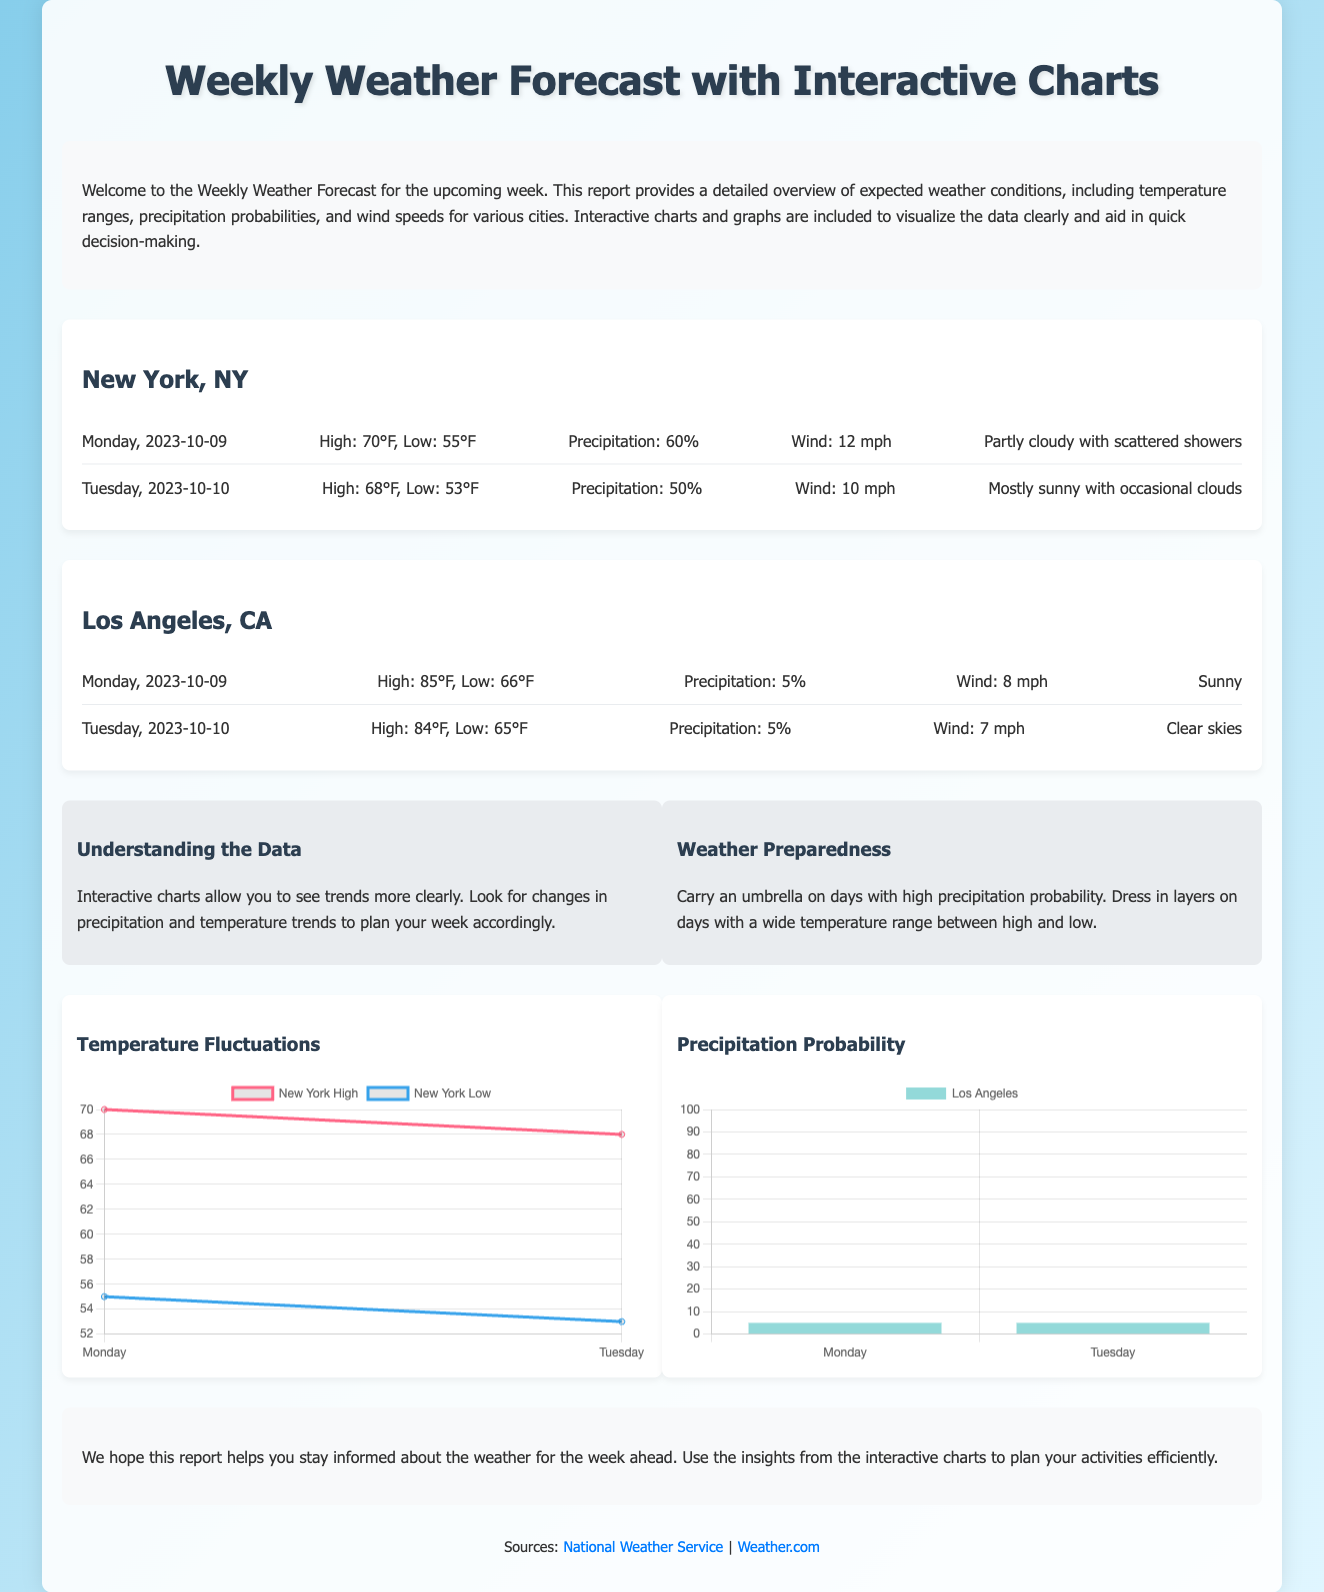What is the high temperature forecast for New York on Monday? The high temperature forecast for New York on Monday is listed in the forecast section of the document.
Answer: 70°F What is the wind speed expected in Los Angeles on Tuesday? The wind speed for Los Angeles on Tuesday is detailed in the city forecast section for Los Angeles.
Answer: 7 mph What is the precipitation probability for New York on Tuesday? The precipitation probability for New York on Tuesday is mentioned in the forecast details for that day.
Answer: 50% Which city has a sunny forecast? The forecast for Los Angeles indicates clear skies, which means a sunny day.
Answer: Los Angeles What is the overall theme of the document? The theme revolves around providing a weekly weather forecast with interactive charts to visualize the weather data.
Answer: Weekly Weather Forecast What should you carry on days with high precipitation probability? The tips section advises carrying umbrellas on days with high precipitation probability.
Answer: Umbrella What are the two types of charts included in the document? The document mentions temperature fluctuations and precipitation probability, which are visualized in charts.
Answer: Temperature Fluctuations, Precipitation Probability What color represents New York's high temperature in the chart? The color assigned to New York's high temperature in the temperature chart is specified through the chart's dataset.
Answer: rgb(255, 99, 132) Which day has the lowest low temperature forecast for New York? The low temperatures for each day in the New York forecasts allow us to determine the day with the lowest low temperature.
Answer: Tuesday 